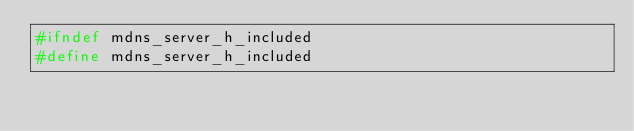<code> <loc_0><loc_0><loc_500><loc_500><_C_>#ifndef mdns_server_h_included
#define mdns_server_h_included
</code> 